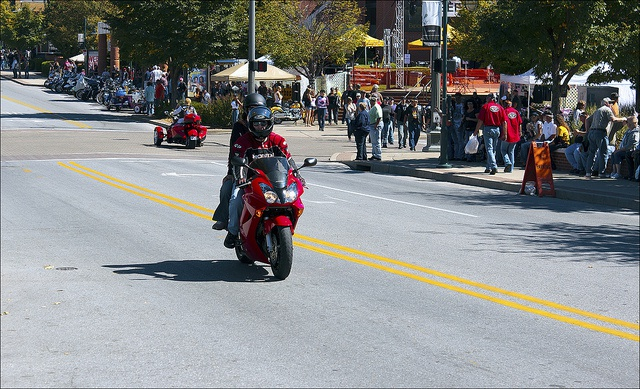Describe the objects in this image and their specific colors. I can see people in black, gray, navy, and darkgray tones, motorcycle in black, maroon, gray, and darkgray tones, people in black, gray, blue, and darkblue tones, people in black, maroon, navy, and blue tones, and motorcycle in black, maroon, gray, and brown tones in this image. 